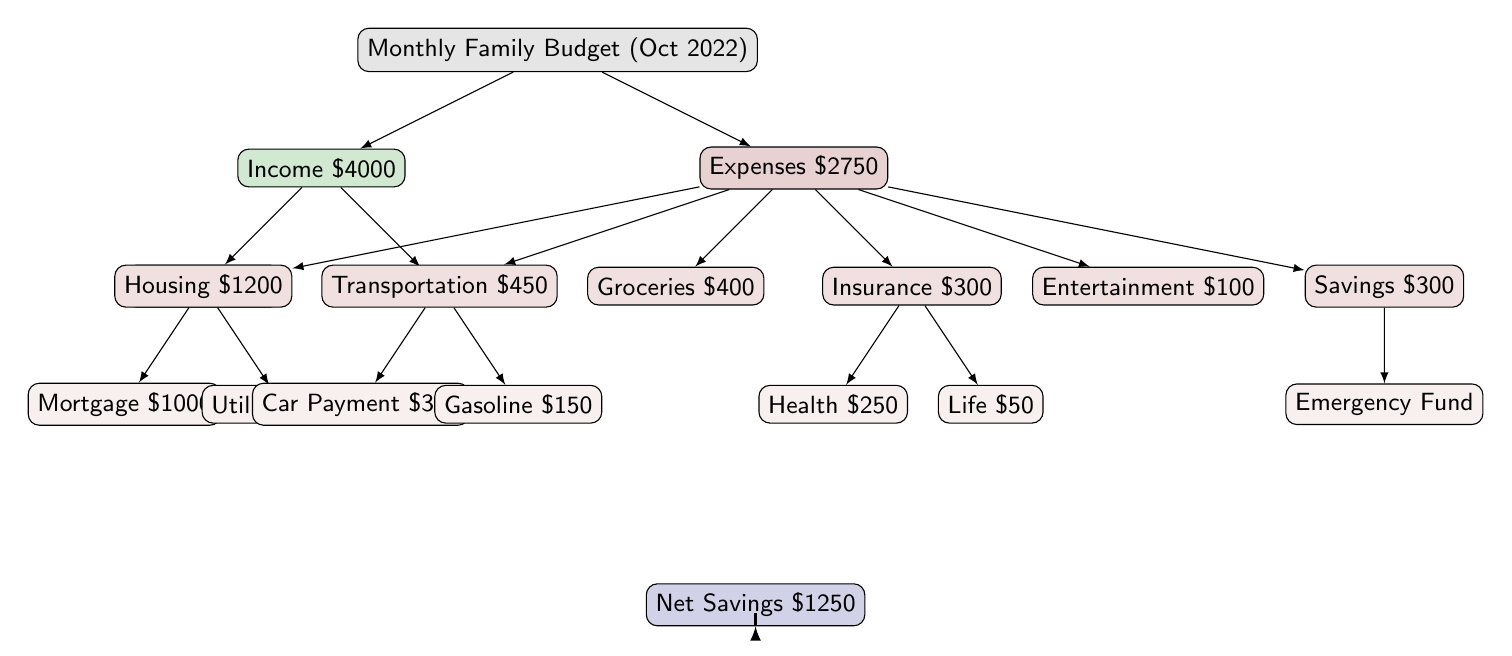What is the total income for October 2022? The diagram shows that the total income is represented at the top level as \$4000. This includes the detailed components of salary and freelance income, which are \$3500 and \$500 respectively, but the total can be directly taken from the income node.
Answer: \$4000 How much was spent on housing? In the diagram, housing expenses are explicitly stated under the expenses node as \$1200. This includes the mortgage and utilities, but again the question is about the total for housing which is directly available in the diagram.
Answer: \$1200 What are the total expenses for October 2022? The total expenses are presented at the expenses node level as \$2750. This encompasses the various detailed expenses such as housing, transportation, groceries, etc., but the overall total is what is recorded in the main expenses node.
Answer: \$2750 How much did the family save in October 2022? The net savings at the bottom of the diagram is noted as \$1250. This is the financial figure after subtracting total expenses from total income. The computation isn't explicitly shown in the diagram, but the net savings value is displayed clearly as an outcome.
Answer: \$1250 What is the amount allocated for transportation expenses? The diagram specifies transportation expenses as \$450 under the expenses branch. This is indicated distinctly at the second level of expenses and includes subcategories, but the question addresses only the transportation total.
Answer: \$450 What percentage of the income was spent on groceries? To find the percentage spent on groceries, we use the grocery expense, which is \$400, divided by the total income of \$4000, giving 400/4000 = 0.1 or 10%. So, 10% of the income was spent on groceries. The answer requires simple division of figures provided in the diagram.
Answer: 10% How much is spent on insurance in total? Under the insurance category in the expenses node, the total is given as \$300, which is made up of health insurance costing \$250 and life insurance costing \$50. The direct question asks for the total insurance amount, which is readily visible in the diagram.
Answer: \$300 Who earns more: salary or freelance? The salary is listed as \$3500 and freelance as \$500 in the income section. By comparing these values, it can be easily determined that the salary is greater than the freelance income. The answer comes from a straightforward observation of the two income categories.
Answer: Salary What is the highest expense category? The highest expense category noted in the diagram is housing, which totals \$1200. This is the largest singular value compared to all other expense categories shown in the diagram. This direct observation leads to the answer.
Answer: Housing 